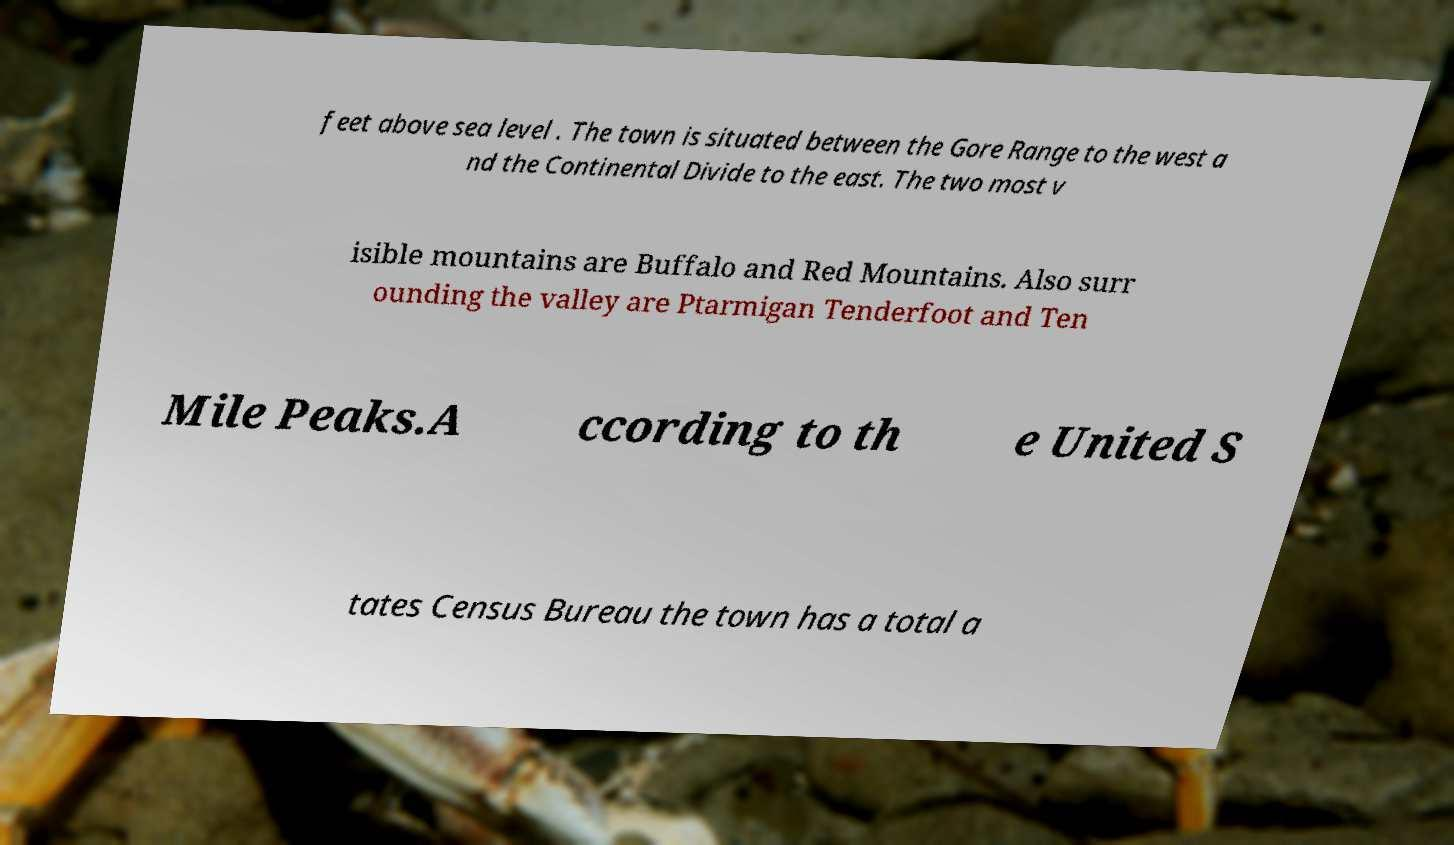For documentation purposes, I need the text within this image transcribed. Could you provide that? feet above sea level . The town is situated between the Gore Range to the west a nd the Continental Divide to the east. The two most v isible mountains are Buffalo and Red Mountains. Also surr ounding the valley are Ptarmigan Tenderfoot and Ten Mile Peaks.A ccording to th e United S tates Census Bureau the town has a total a 